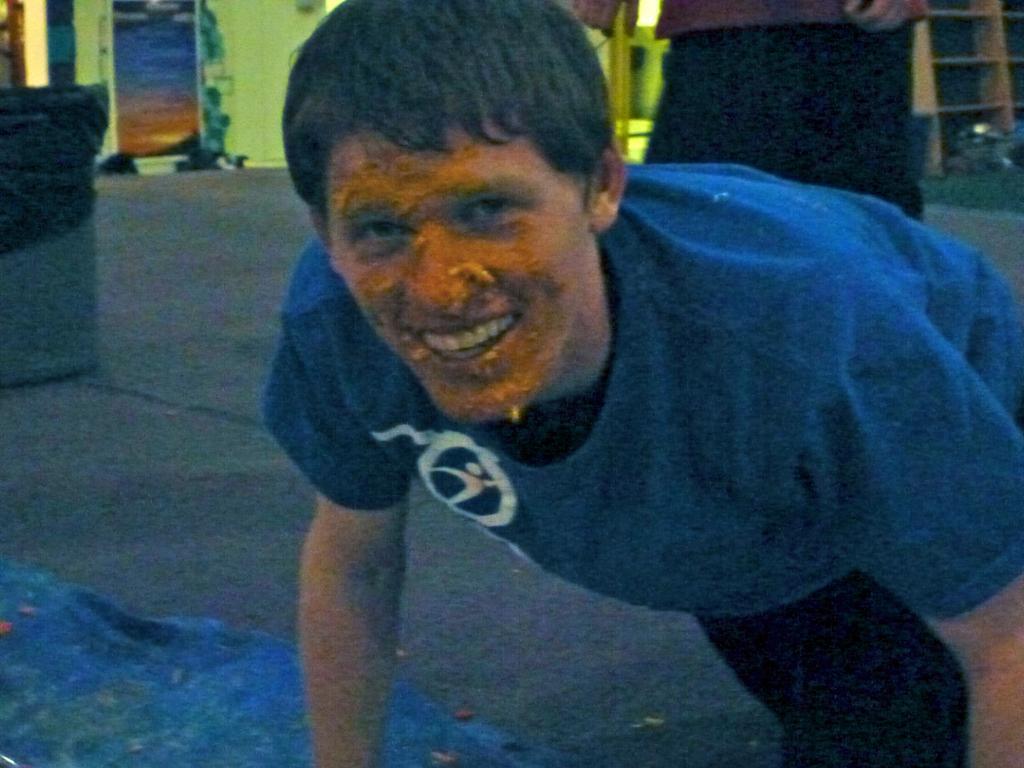Could you give a brief overview of what you see in this image? A person is present wearing a blue t shirt. There is something on his face. There is another person behind him. 